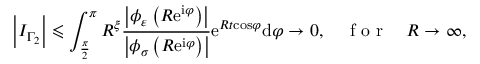Convert formula to latex. <formula><loc_0><loc_0><loc_500><loc_500>\left | I _ { \Gamma _ { 2 } } \right | \leqslant \int _ { \frac { \pi } { 2 } } ^ { \pi } R ^ { \xi } \frac { \left | \phi _ { \varepsilon } \left ( R e ^ { i \varphi } \right ) \right | } { \left | \phi _ { \sigma } \left ( R e ^ { i \varphi } \right ) \right | } e ^ { R t \cos \varphi } d \varphi \rightarrow 0 , \quad f o r \quad R \rightarrow \infty ,</formula> 